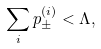Convert formula to latex. <formula><loc_0><loc_0><loc_500><loc_500>\sum _ { i } p _ { \pm } ^ { ( i ) } < \Lambda ,</formula> 